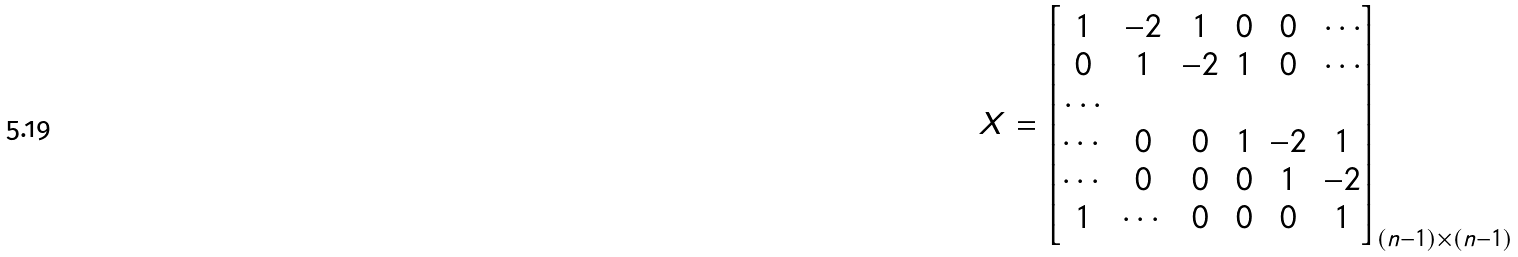Convert formula to latex. <formula><loc_0><loc_0><loc_500><loc_500>X = \begin{bmatrix} 1 & - 2 & 1 & 0 & 0 & \cdots \\ 0 & 1 & - 2 & 1 & 0 & \cdots \\ \cdots \\ \cdots & 0 & 0 & 1 & - 2 & 1 \\ \cdots & 0 & 0 & 0 & 1 & - 2 \\ 1 & \cdots & 0 & 0 & 0 & 1 \end{bmatrix} _ { ( n - 1 ) \times ( n - 1 ) }</formula> 